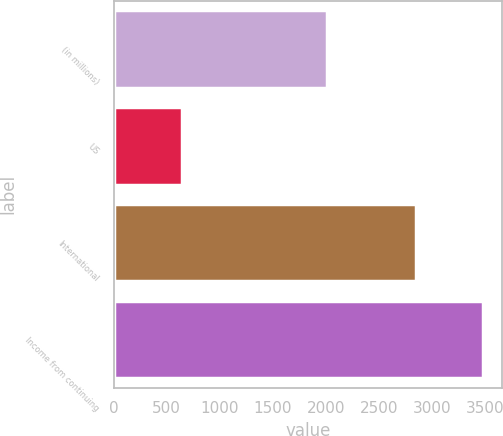Convert chart. <chart><loc_0><loc_0><loc_500><loc_500><bar_chart><fcel>(in millions)<fcel>US<fcel>International<fcel>Income from continuing<nl><fcel>2015<fcel>639<fcel>2847<fcel>3486<nl></chart> 